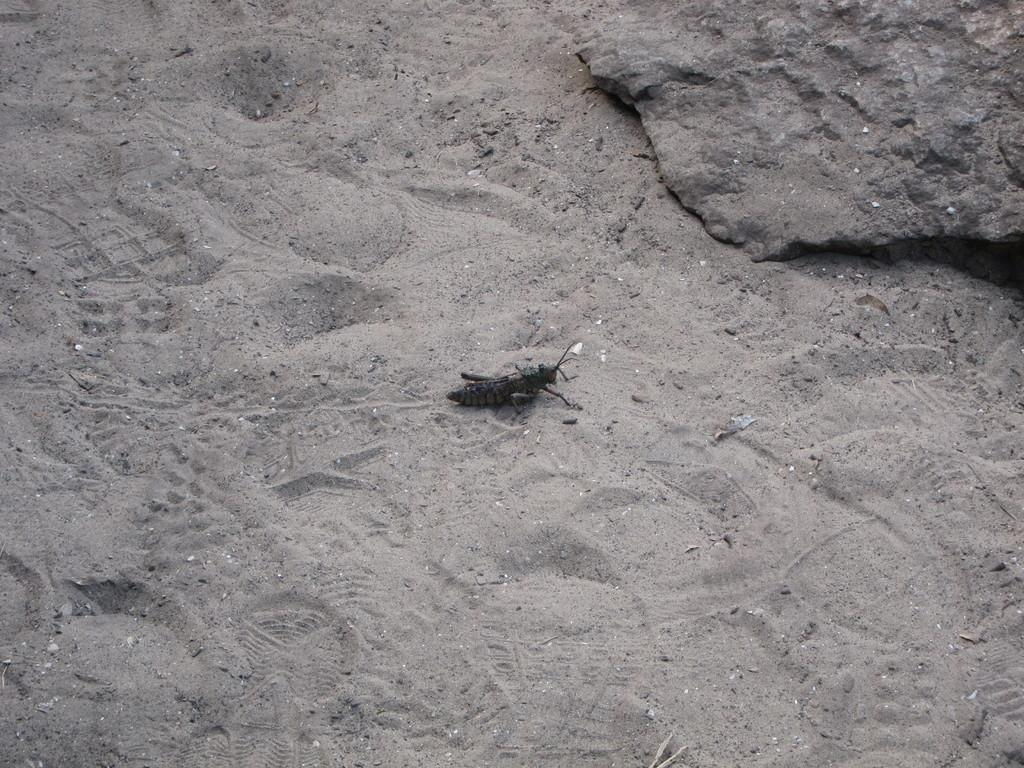What type of terrain is depicted in the image? There is sand in the image. What living organism can be seen in the image? There is a black-colored insect in the image. What evidence of human or animal presence can be observed in the image? There are footprints visible in the image. What type of stick can be seen in the image? There is no stick present in the image. How much debt is the insect carrying in the image? There is no indication of debt in the image, and insects do not carry debt. 